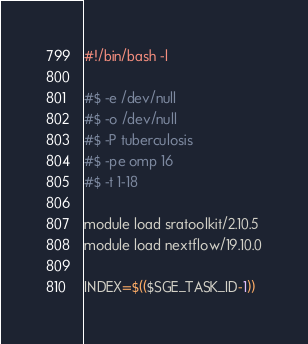<code> <loc_0><loc_0><loc_500><loc_500><_Bash_>#!/bin/bash -l

#$ -e /dev/null
#$ -o /dev/null
#$ -P tuberculosis
#$ -pe omp 16
#$ -t 1-18

module load sratoolkit/2.10.5
module load nextflow/19.10.0

INDEX=$(($SGE_TASK_ID-1))
</code> 